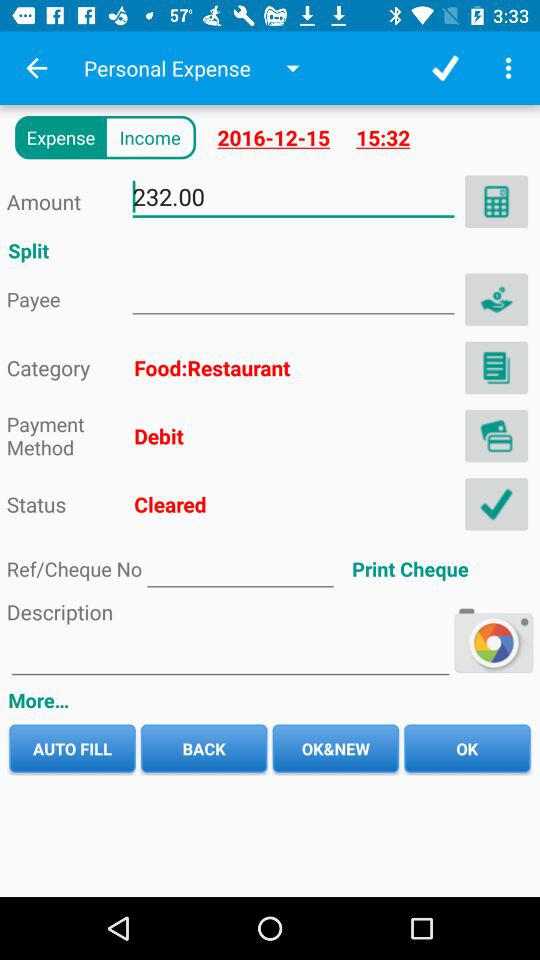What is the category? The category is "Food:Restaurant". 